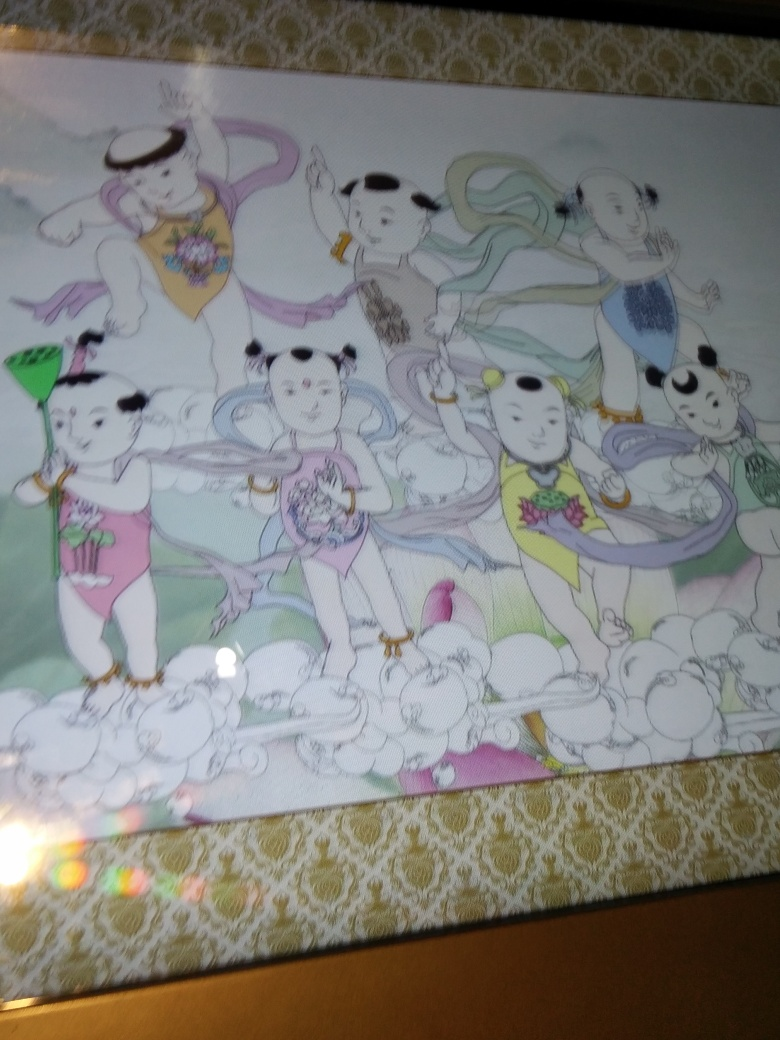Is the image of low quality? While the content of the image depicts a colorful illustration of characters that appear to be enjoying themselves, the photograph itself seems to have been taken at an angle, and the glare on the image suggests that it is of suboptimal quality. It would be ideal to have a clearer, more direct shot of the illustration to fully appreciate the details and vibrancy of the artwork. 